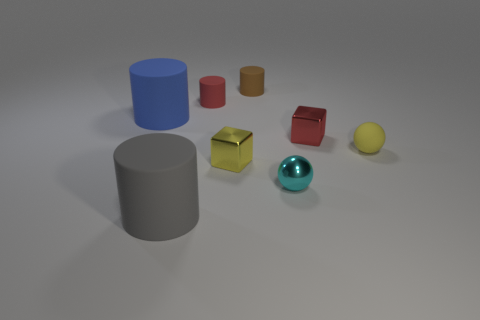There is a cube that is to the right of the tiny matte cylinder behind the tiny red object that is on the left side of the small red block; what is it made of?
Your answer should be very brief. Metal. There is a cyan metallic thing that is the same size as the red block; what shape is it?
Ensure brevity in your answer.  Sphere. How many objects are small cyan shiny cubes or large matte things that are to the left of the big gray matte object?
Your response must be concise. 1. Do the tiny block that is to the right of the cyan thing and the tiny cylinder on the right side of the small red matte thing have the same material?
Keep it short and to the point. No. What shape is the tiny object that is the same color as the tiny matte sphere?
Your answer should be compact. Cube. How many brown things are either big objects or metallic blocks?
Your response must be concise. 0. What size is the gray rubber cylinder?
Provide a short and direct response. Large. Is the number of large cylinders that are behind the gray object greater than the number of big purple matte blocks?
Provide a succinct answer. Yes. There is a yellow matte thing; how many big matte cylinders are behind it?
Ensure brevity in your answer.  1. Is there a brown rubber object that has the same size as the gray rubber cylinder?
Give a very brief answer. No. 